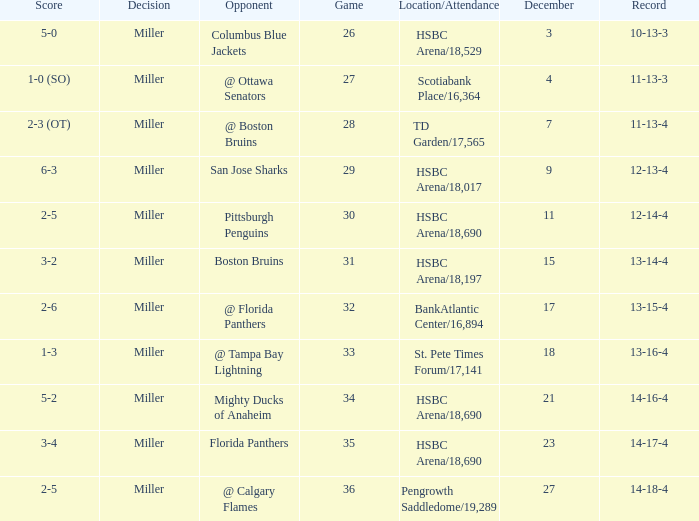Name the number of game 2-6 1.0. 